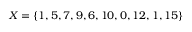<formula> <loc_0><loc_0><loc_500><loc_500>X = \{ 1 , 5 , 7 , 9 , 6 , 1 0 , 0 , 1 2 , 1 , 1 5 \}</formula> 